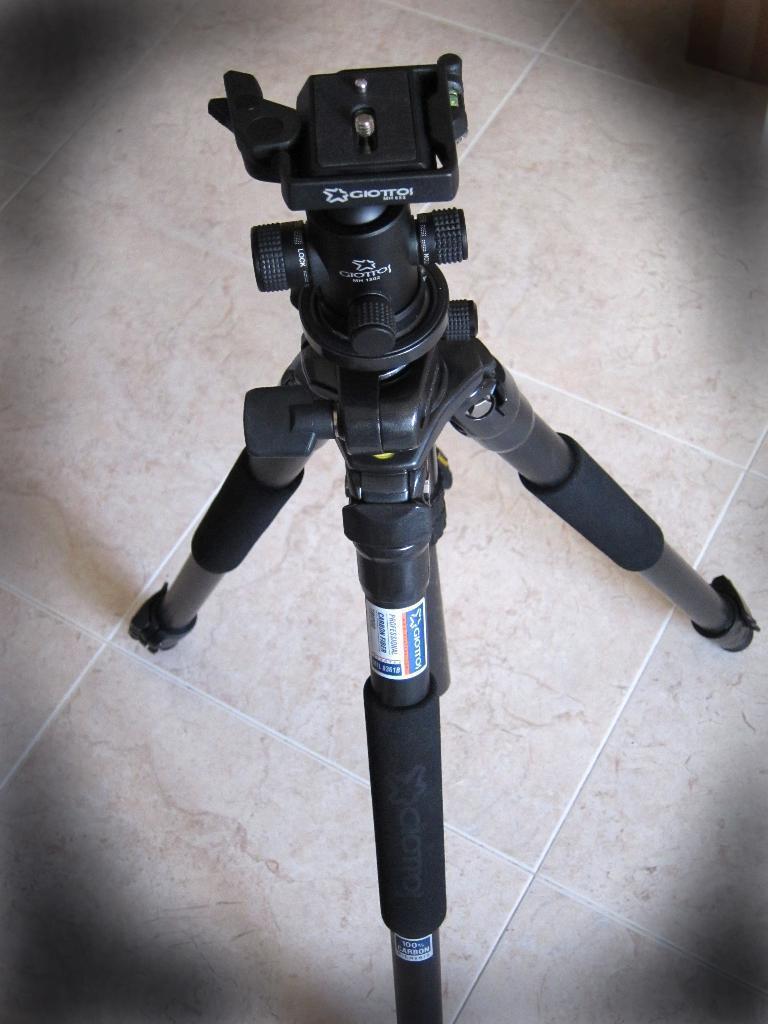Describe this image in one or two sentences. The picture consists of a camera tripod stand. At the bottom there is floor. 